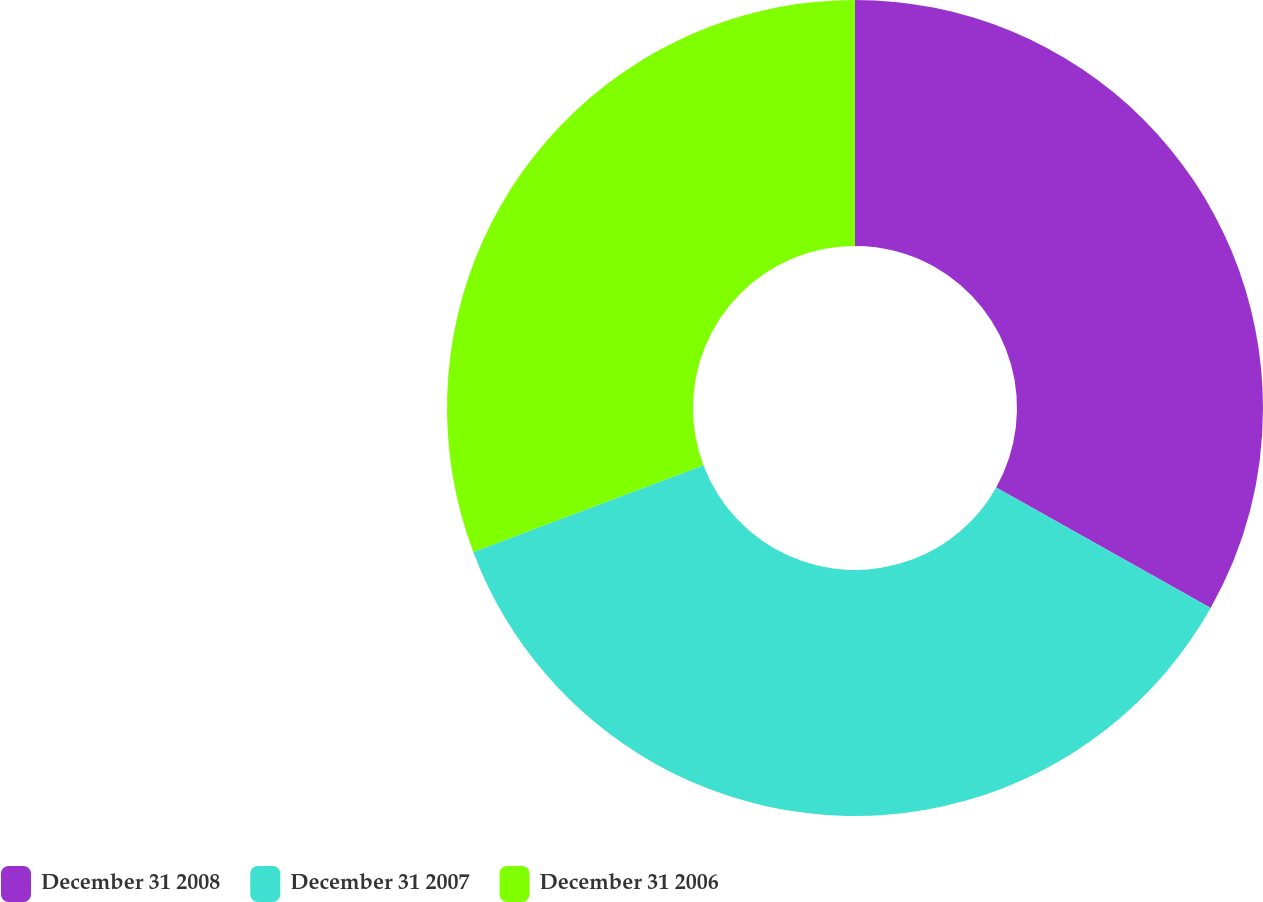Convert chart to OTSL. <chart><loc_0><loc_0><loc_500><loc_500><pie_chart><fcel>December 31 2008<fcel>December 31 2007<fcel>December 31 2006<nl><fcel>33.15%<fcel>36.11%<fcel>30.74%<nl></chart> 